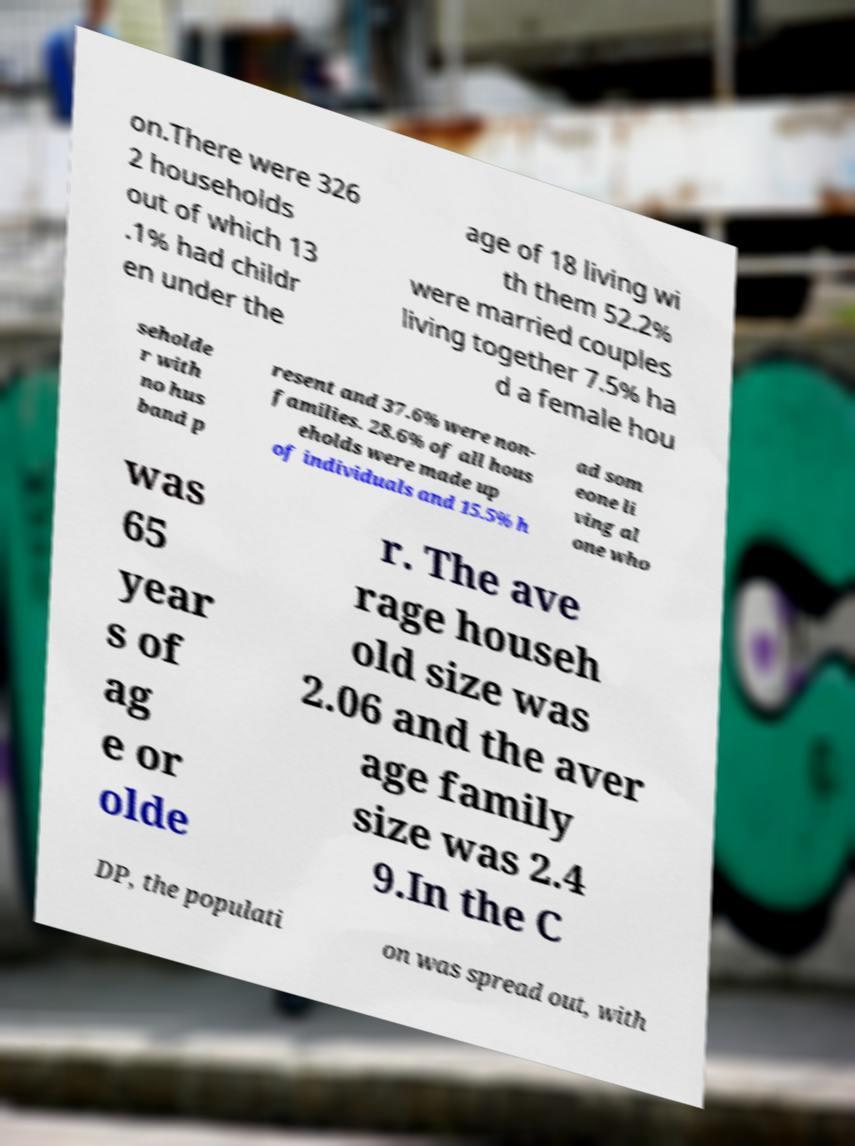Can you accurately transcribe the text from the provided image for me? on.There were 326 2 households out of which 13 .1% had childr en under the age of 18 living wi th them 52.2% were married couples living together 7.5% ha d a female hou seholde r with no hus band p resent and 37.6% were non- families. 28.6% of all hous eholds were made up of individuals and 15.5% h ad som eone li ving al one who was 65 year s of ag e or olde r. The ave rage househ old size was 2.06 and the aver age family size was 2.4 9.In the C DP, the populati on was spread out, with 